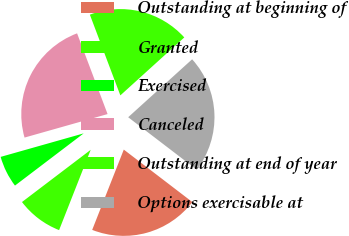Convert chart to OTSL. <chart><loc_0><loc_0><loc_500><loc_500><pie_chart><fcel>Outstanding at beginning of<fcel>Granted<fcel>Exercised<fcel>Canceled<fcel>Outstanding at end of year<fcel>Options exercisable at<nl><fcel>20.57%<fcel>8.69%<fcel>5.95%<fcel>23.64%<fcel>19.03%<fcel>22.11%<nl></chart> 